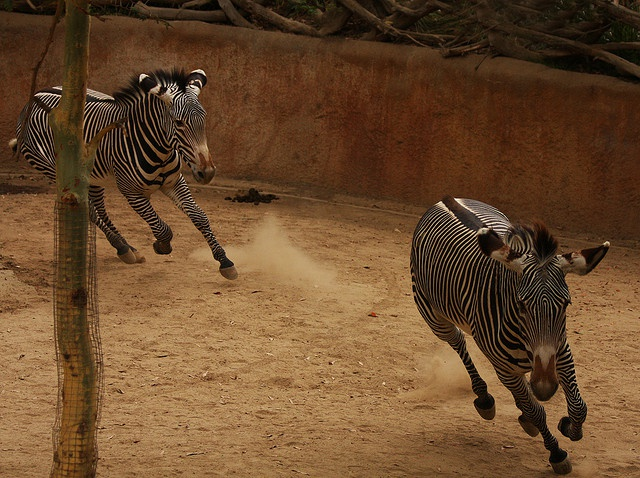Describe the objects in this image and their specific colors. I can see zebra in black, maroon, and gray tones and zebra in black, maroon, and gray tones in this image. 